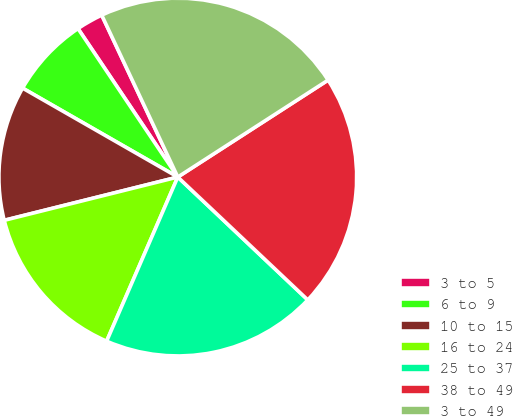Convert chart. <chart><loc_0><loc_0><loc_500><loc_500><pie_chart><fcel>3 to 5<fcel>6 to 9<fcel>10 to 15<fcel>16 to 24<fcel>25 to 37<fcel>38 to 49<fcel>3 to 49<nl><fcel>2.43%<fcel>7.3%<fcel>12.17%<fcel>14.6%<fcel>19.46%<fcel>21.17%<fcel>22.87%<nl></chart> 